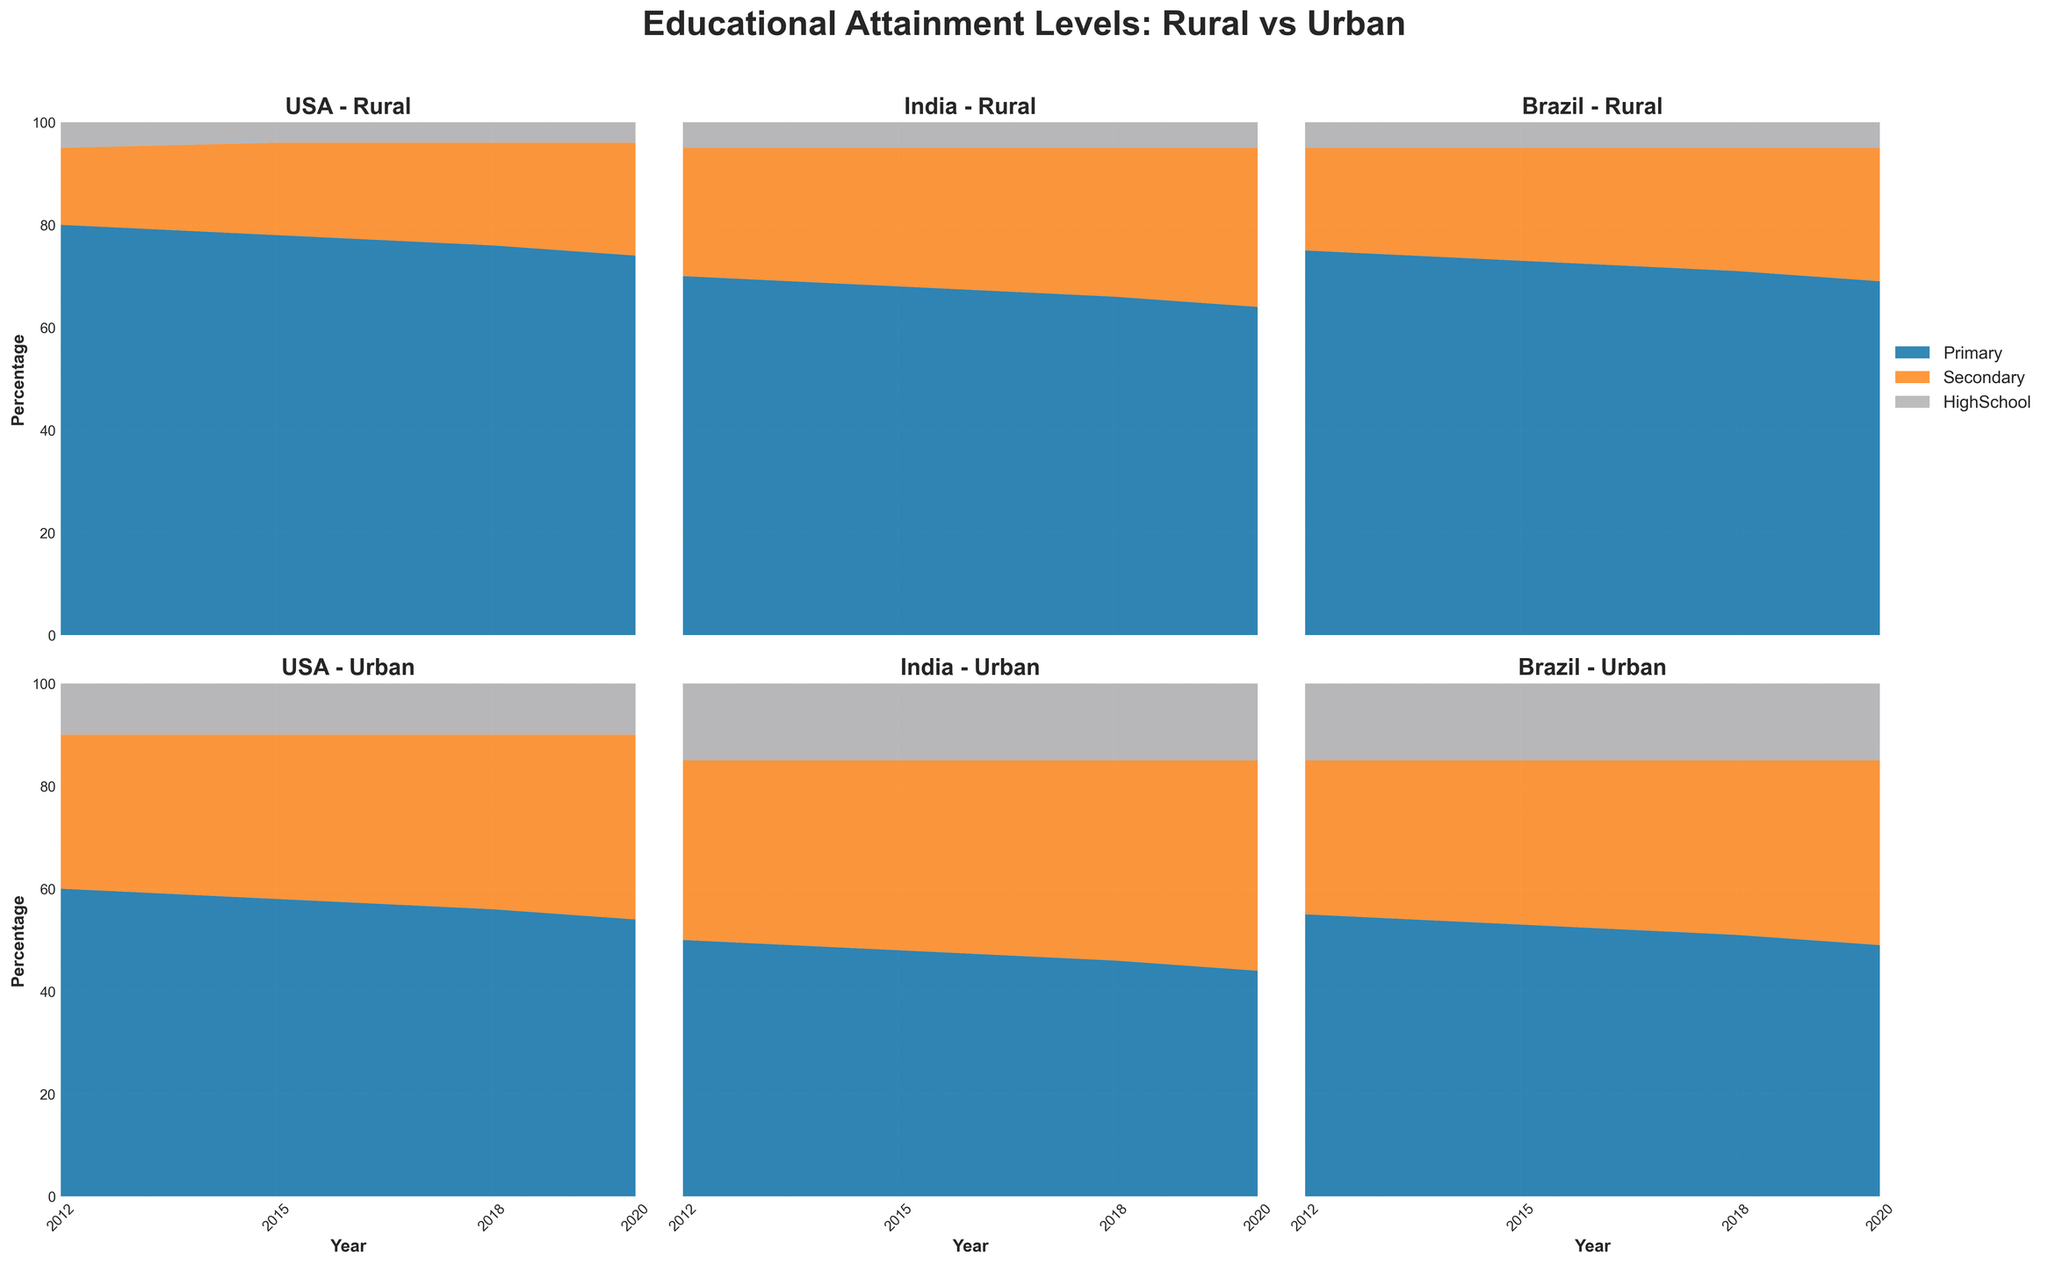What is the title of the figure? The title is located at the top of the figure, often describing the content or the data being visualized. In this case, it describes educational attainment levels for rural versus urban children.
Answer: Educational Attainment Levels: Rural vs Urban Which education level consistently shows the lowest percentage in all countries? By examining all the subplots, the area representing 'HighSchool' is always at the top with the smallest area compared to 'Primary' and 'Secondary'.
Answer: HighSchool How did the percentage of primary education in rural USA change from 2012 to 2020? Observing the 'USA - Rural' subplot, the percentage for 'Primary' level decreases from 80% in 2012 to 74% in 2020.
Answer: Decreased by 6% Between rural and urban children in Brazil, which group saw a larger decrease in primary education percentage from 2012 to 2020? By comparing both 'Brazil - Rural' and 'Brazil - Urban' subplots, the percentage decrease for 'Primary' in Rural went from 75% to 69% (6%), and in Urban from 55% to 49% (6%). The decreases are equal.
Answer: Both saw a decrease of 6% In which year did urban children in India have the highest percentage of secondary education? Looking at the 'India - Urban' subplot, the highest percentage of 'Secondary' is in 2020 with 41%.
Answer: 2020 What's the general trend for secondary education across all countries from 2012 to 2020? Analyzing all subplots, there appears to be a general increase in the 'Secondary' area for both rural and urban locations in all countries over the years.
Answer: Increasing trend Which country shows the greatest disparity between rural and urban high school education levels in 2020? Comparing 2020 data across subplots, the disparity between 'Urban' and 'Rural' in high school percentage is most significant in Brazil, with Urban at 15% and Rural at 5%, a 10% difference.
Answer: Brazil Is there a country where rural children have a higher percentage of secondary education than urban children? Comparing both rural and urban subplots for each country, at no point do rural children exceed their urban counterparts in secondary education percentages.
Answer: No Which education level has the most uniform distribution percentages across rural and urban locations and all countries in 2020? Observing the data for 2020 in all subplots, 'HighSchool' roughly stays around 5% for rural and 10-15% for urban consistently across all countries.
Answer: HighSchool How did the educational attainment for primary education change for urban children in the USA from 2012 to 2018? Looking at 'USA - Urban', the primary education percentage decreased from 60% in 2012 to 56% in 2018.
Answer: Decreased by 4% 